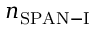<formula> <loc_0><loc_0><loc_500><loc_500>n _ { S P A N - I }</formula> 